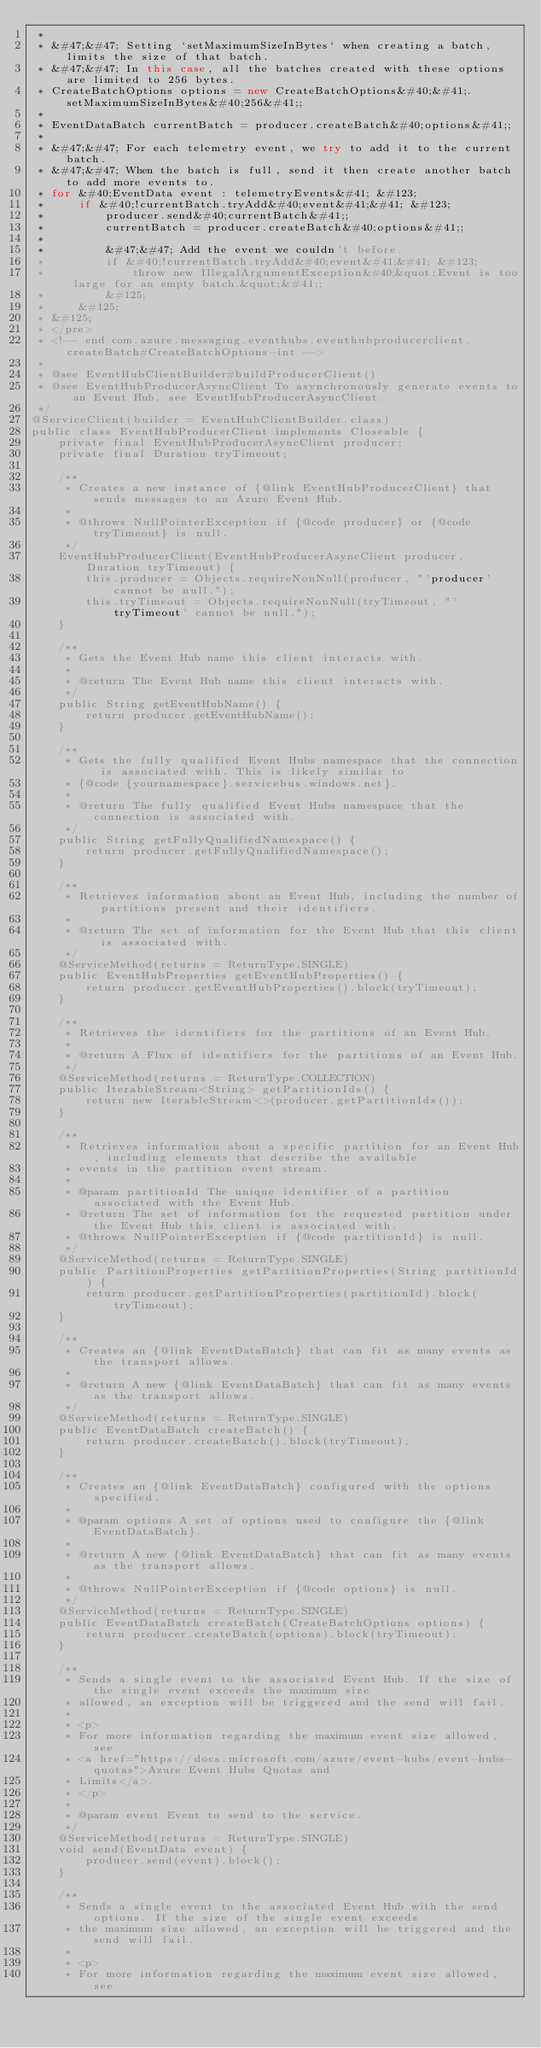<code> <loc_0><loc_0><loc_500><loc_500><_Java_> *
 * &#47;&#47; Setting `setMaximumSizeInBytes` when creating a batch, limits the size of that batch.
 * &#47;&#47; In this case, all the batches created with these options are limited to 256 bytes.
 * CreateBatchOptions options = new CreateBatchOptions&#40;&#41;.setMaximumSizeInBytes&#40;256&#41;;
 *
 * EventDataBatch currentBatch = producer.createBatch&#40;options&#41;;
 *
 * &#47;&#47; For each telemetry event, we try to add it to the current batch.
 * &#47;&#47; When the batch is full, send it then create another batch to add more events to.
 * for &#40;EventData event : telemetryEvents&#41; &#123;
 *     if &#40;!currentBatch.tryAdd&#40;event&#41;&#41; &#123;
 *         producer.send&#40;currentBatch&#41;;
 *         currentBatch = producer.createBatch&#40;options&#41;;
 *
 *         &#47;&#47; Add the event we couldn't before.
 *         if &#40;!currentBatch.tryAdd&#40;event&#41;&#41; &#123;
 *             throw new IllegalArgumentException&#40;&quot;Event is too large for an empty batch.&quot;&#41;;
 *         &#125;
 *     &#125;
 * &#125;
 * </pre>
 * <!-- end com.azure.messaging.eventhubs.eventhubproducerclient.createBatch#CreateBatchOptions-int -->
 *
 * @see EventHubClientBuilder#buildProducerClient()
 * @see EventHubProducerAsyncClient To asynchronously generate events to an Event Hub, see EventHubProducerAsyncClient.
 */
@ServiceClient(builder = EventHubClientBuilder.class)
public class EventHubProducerClient implements Closeable {
    private final EventHubProducerAsyncClient producer;
    private final Duration tryTimeout;

    /**
     * Creates a new instance of {@link EventHubProducerClient} that sends messages to an Azure Event Hub.
     *
     * @throws NullPointerException if {@code producer} or {@code tryTimeout} is null.
     */
    EventHubProducerClient(EventHubProducerAsyncClient producer, Duration tryTimeout) {
        this.producer = Objects.requireNonNull(producer, "'producer' cannot be null.");
        this.tryTimeout = Objects.requireNonNull(tryTimeout, "'tryTimeout' cannot be null.");
    }

    /**
     * Gets the Event Hub name this client interacts with.
     *
     * @return The Event Hub name this client interacts with.
     */
    public String getEventHubName() {
        return producer.getEventHubName();
    }

    /**
     * Gets the fully qualified Event Hubs namespace that the connection is associated with. This is likely similar to
     * {@code {yournamespace}.servicebus.windows.net}.
     *
     * @return The fully qualified Event Hubs namespace that the connection is associated with.
     */
    public String getFullyQualifiedNamespace() {
        return producer.getFullyQualifiedNamespace();
    }

    /**
     * Retrieves information about an Event Hub, including the number of partitions present and their identifiers.
     *
     * @return The set of information for the Event Hub that this client is associated with.
     */
    @ServiceMethod(returns = ReturnType.SINGLE)
    public EventHubProperties getEventHubProperties() {
        return producer.getEventHubProperties().block(tryTimeout);
    }

    /**
     * Retrieves the identifiers for the partitions of an Event Hub.
     *
     * @return A Flux of identifiers for the partitions of an Event Hub.
     */
    @ServiceMethod(returns = ReturnType.COLLECTION)
    public IterableStream<String> getPartitionIds() {
        return new IterableStream<>(producer.getPartitionIds());
    }

    /**
     * Retrieves information about a specific partition for an Event Hub, including elements that describe the available
     * events in the partition event stream.
     *
     * @param partitionId The unique identifier of a partition associated with the Event Hub.
     * @return The set of information for the requested partition under the Event Hub this client is associated with.
     * @throws NullPointerException if {@code partitionId} is null.
     */
    @ServiceMethod(returns = ReturnType.SINGLE)
    public PartitionProperties getPartitionProperties(String partitionId) {
        return producer.getPartitionProperties(partitionId).block(tryTimeout);
    }

    /**
     * Creates an {@link EventDataBatch} that can fit as many events as the transport allows.
     *
     * @return A new {@link EventDataBatch} that can fit as many events as the transport allows.
     */
    @ServiceMethod(returns = ReturnType.SINGLE)
    public EventDataBatch createBatch() {
        return producer.createBatch().block(tryTimeout);
    }

    /**
     * Creates an {@link EventDataBatch} configured with the options specified.
     *
     * @param options A set of options used to configure the {@link EventDataBatch}.
     *
     * @return A new {@link EventDataBatch} that can fit as many events as the transport allows.
     *
     * @throws NullPointerException if {@code options} is null.
     */
    @ServiceMethod(returns = ReturnType.SINGLE)
    public EventDataBatch createBatch(CreateBatchOptions options) {
        return producer.createBatch(options).block(tryTimeout);
    }

    /**
     * Sends a single event to the associated Event Hub. If the size of the single event exceeds the maximum size
     * allowed, an exception will be triggered and the send will fail.
     *
     * <p>
     * For more information regarding the maximum event size allowed, see
     * <a href="https://docs.microsoft.com/azure/event-hubs/event-hubs-quotas">Azure Event Hubs Quotas and
     * Limits</a>.
     * </p>
     *
     * @param event Event to send to the service.
     */
    @ServiceMethod(returns = ReturnType.SINGLE)
    void send(EventData event) {
        producer.send(event).block();
    }

    /**
     * Sends a single event to the associated Event Hub with the send options. If the size of the single event exceeds
     * the maximum size allowed, an exception will be triggered and the send will fail.
     *
     * <p>
     * For more information regarding the maximum event size allowed, see</code> 